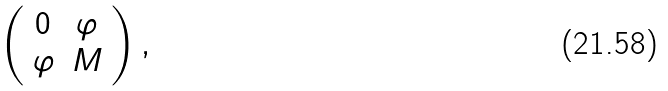Convert formula to latex. <formula><loc_0><loc_0><loc_500><loc_500>\left ( \begin{array} { c c } 0 & \varphi \\ \varphi & M \end{array} \right ) ,</formula> 